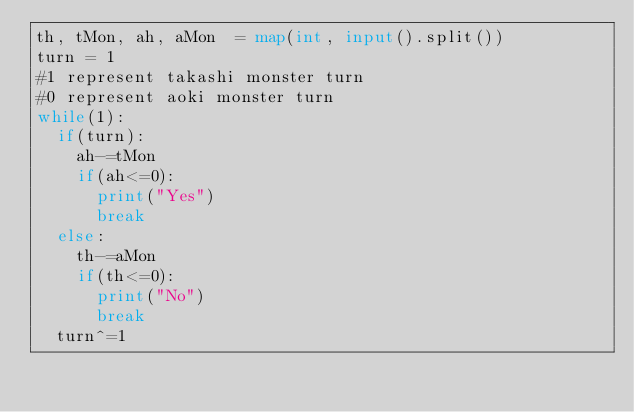Convert code to text. <code><loc_0><loc_0><loc_500><loc_500><_Python_>th, tMon, ah, aMon  = map(int, input().split())
turn = 1
#1 represent takashi monster turn
#0 represent aoki monster turn
while(1):
  if(turn):
    ah-=tMon
    if(ah<=0):
      print("Yes")
      break
  else:
    th-=aMon
    if(th<=0):
      print("No")
      break
  turn^=1</code> 